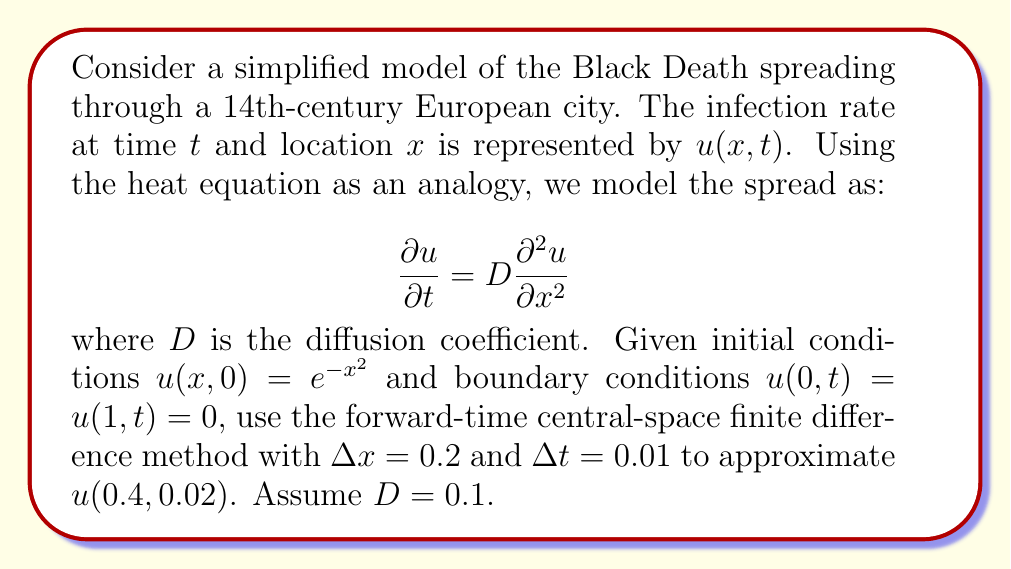Could you help me with this problem? To solve this problem, we'll follow these steps:

1) The forward-time central-space finite difference scheme for the heat equation is:

   $$u_{i}^{n+1} = u_{i}^n + \frac{D\Delta t}{(\Delta x)^2}(u_{i+1}^n - 2u_{i}^n + u_{i-1}^n)$$

2) We need to calculate $u(0.4, 0.02)$, which corresponds to $x = 0.4$ and $t = 0.02$.

3) With $\Delta x = 0.2$, the spatial grid points are:
   $x_0 = 0, x_1 = 0.2, x_2 = 0.4, x_3 = 0.6, x_4 = 0.8, x_5 = 1$

4) With $\Delta t = 0.01$, we need to calculate two time steps:
   $t_0 = 0, t_1 = 0.01, t_2 = 0.02$

5) Initial conditions at $t = 0$:
   $u_0^0 = 0$
   $u_1^0 = e^{-(0.2)^2} \approx 0.9608$
   $u_2^0 = e^{-(0.4)^2} \approx 0.8521$
   $u_3^0 = e^{-(0.6)^2} \approx 0.6977$
   $u_4^0 = e^{-(0.8)^2} \approx 0.5276$
   $u_5^0 = 0$

6) Calculate the coefficient:
   $\frac{D\Delta t}{(\Delta x)^2} = \frac{0.1 \cdot 0.01}{(0.2)^2} = 0.025$

7) For the first time step ($n = 0$ to $n = 1$):
   $u_1^1 = 0.9608 + 0.025(0.8521 - 2 \cdot 0.9608 + 0) \approx 0.9368$
   $u_2^1 = 0.8521 + 0.025(0.6977 - 2 \cdot 0.8521 + 0.9608) \approx 0.8479$
   $u_3^1 = 0.6977 + 0.025(0.5276 - 2 \cdot 0.6977 + 0.8521) \approx 0.7018$

8) For the second time step ($n = 1$ to $n = 2$):
   $u_2^2 = 0.8479 + 0.025(0.7018 - 2 \cdot 0.8479 + 0.9368) \approx 0.8437$

Therefore, $u(0.4, 0.02) \approx u_2^2 \approx 0.8437$.
Answer: 0.8437 